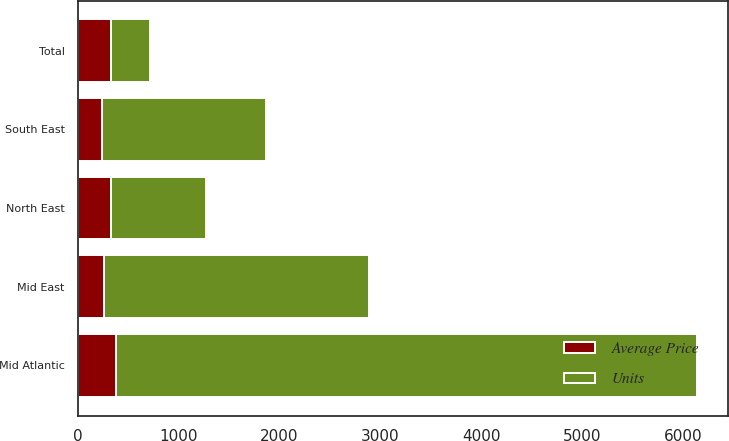Convert chart to OTSL. <chart><loc_0><loc_0><loc_500><loc_500><stacked_bar_chart><ecel><fcel>Mid Atlantic<fcel>North East<fcel>Mid East<fcel>South East<fcel>Total<nl><fcel>Units<fcel>5757<fcel>946<fcel>2625<fcel>1626<fcel>382.9<nl><fcel>Average Price<fcel>382.9<fcel>325.3<fcel>264.2<fcel>243.7<fcel>328.8<nl></chart> 